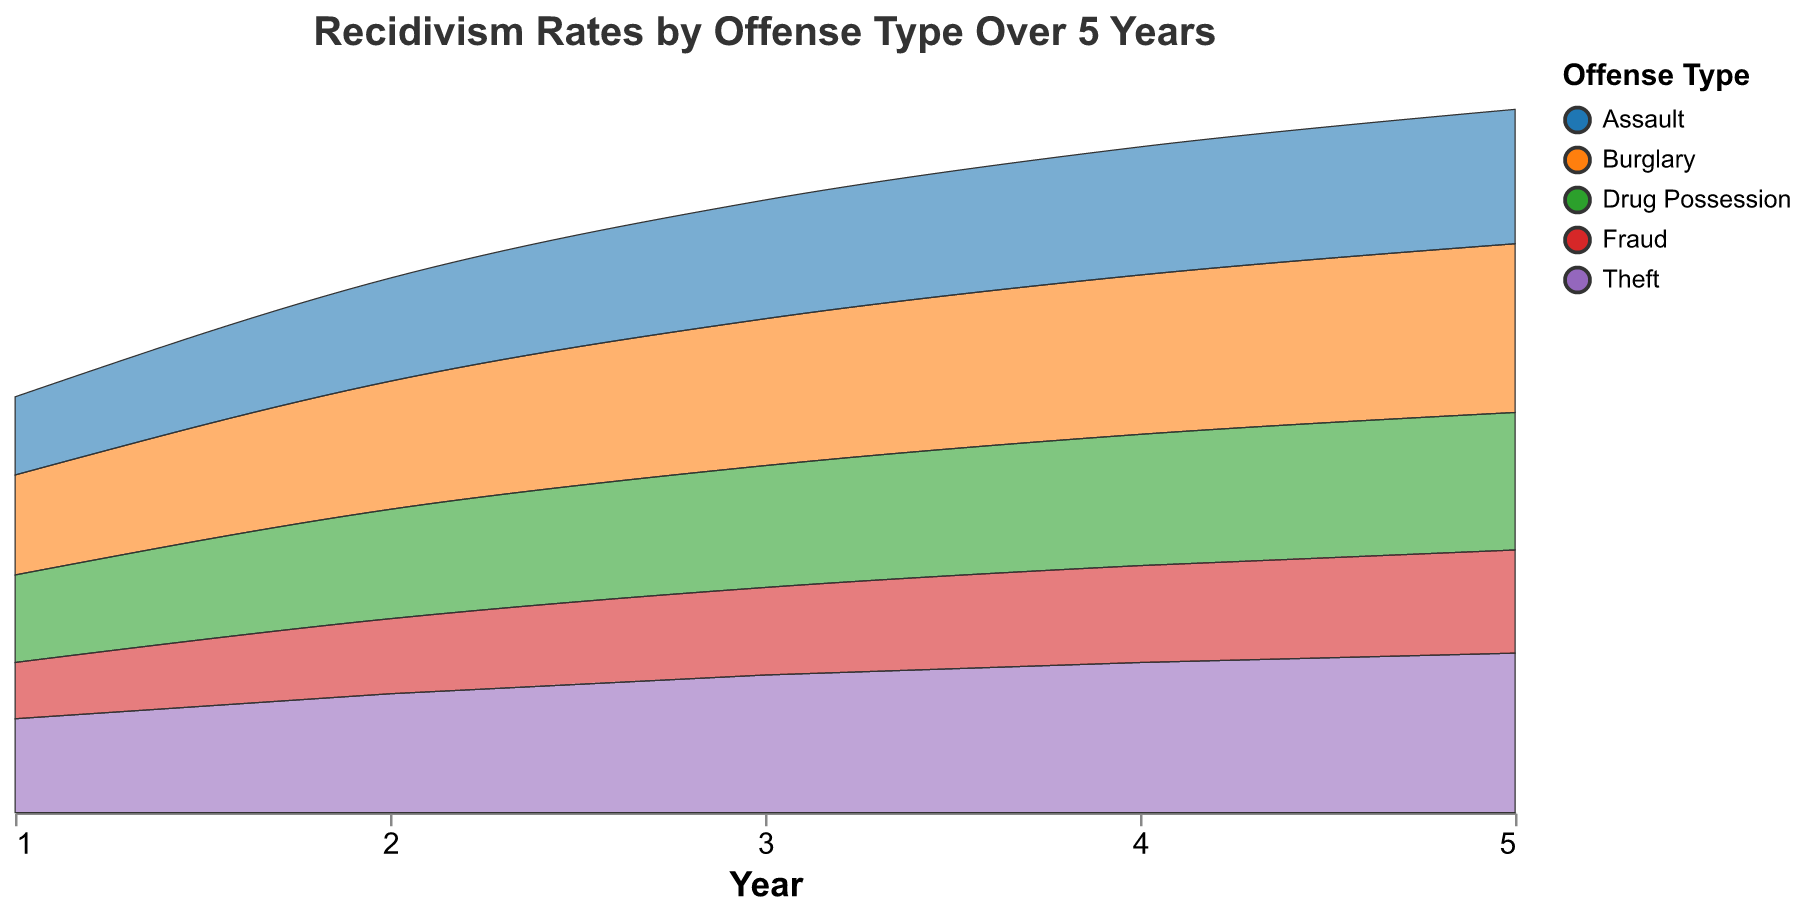Which offense type has the highest recidivism rate in year 5? By looking at the recidivism rates at year 5 for each offense type, Burglary has the highest rate of 0.54.
Answer: Burglary How does the recidivism rate for Fraud change from year 1 to year 5? The recidivism rate for Fraud increases from 0.18 in year 1 to 0.33 in year 5, indicating a consistent rise over the years.
Answer: Increases Which offense type has the lowest recidivism rate in year 1? By comparing the recidivism rates at year 1 for all offense types, Fraud has the lowest rate at 0.18.
Answer: Fraud What is the difference in recidivism rates between year 1 and year 5 for Theft? The recidivism rate for Theft in year 1 is 0.30, and in year 5, it is 0.51. The difference is 0.51 - 0.30 = 0.21.
Answer: 0.21 Among the listed offense types, which one shows the slowest increase in recidivism rate over the 5 years? By examining the rate of increase for each offense type, Fraud shows the slowest increase, going from 0.18 to 0.33 over 5 years.
Answer: Fraud How does the recidivism rate for Drug Possession in year 3 compare to that of Assault in the same year? In year 3, the recidivism rate for Drug Possession is 0.39, while for Assault, it is 0.38. Drug Possession has a slightly higher rate.
Answer: Drug Possession What is the average recidivism rate for Burglary over the 5-year period? To find the average, sum the rates for Burglary over the 5 years (0.32 + 0.41 + 0.47 + 0.51 + 0.54) which equals 2.25, then divide by 5. The average is 2.25 / 5 = 0.45.
Answer: 0.45 Which offense type shows the highest increase in recidivism rate from year 1 to year 2? By comparing the increase from year 1 to year 2 for each offense type, Burglary shows the highest increase from 0.32 to 0.41, with a difference of 0.09.
Answer: Burglary Is there any year when the recidivism rate for Assault is higher than that for Theft? By comparing the recidivism rates for Assault and Theft each year, there is no year where the rate for Assault is higher than that for Theft.
Answer: No What trend is observed in the recidivism rates for all offense types over the 5-year period shown? The observed trend is that the recidivism rates for all offense types consistently increase over the 5-year period.
Answer: Increase 